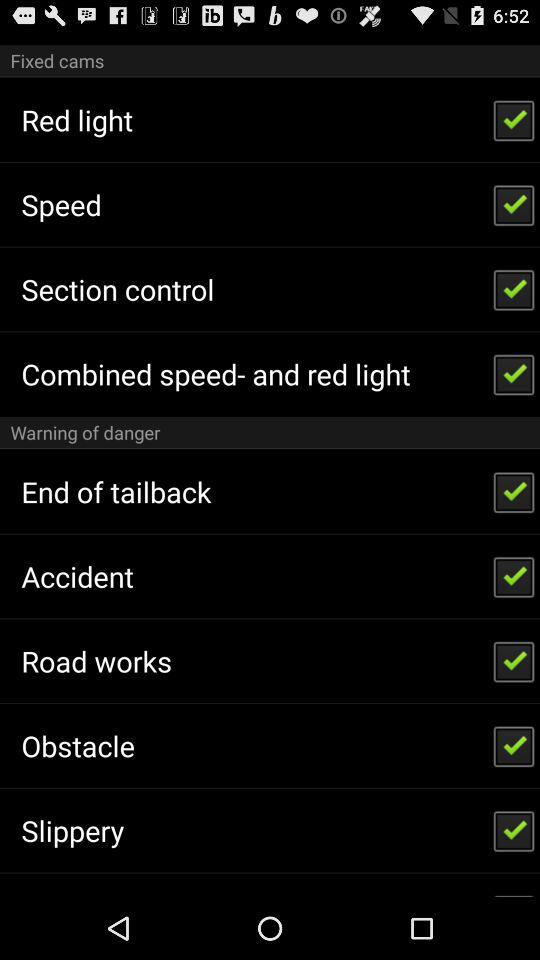What is the status of the "Section control"? The status is "on". 